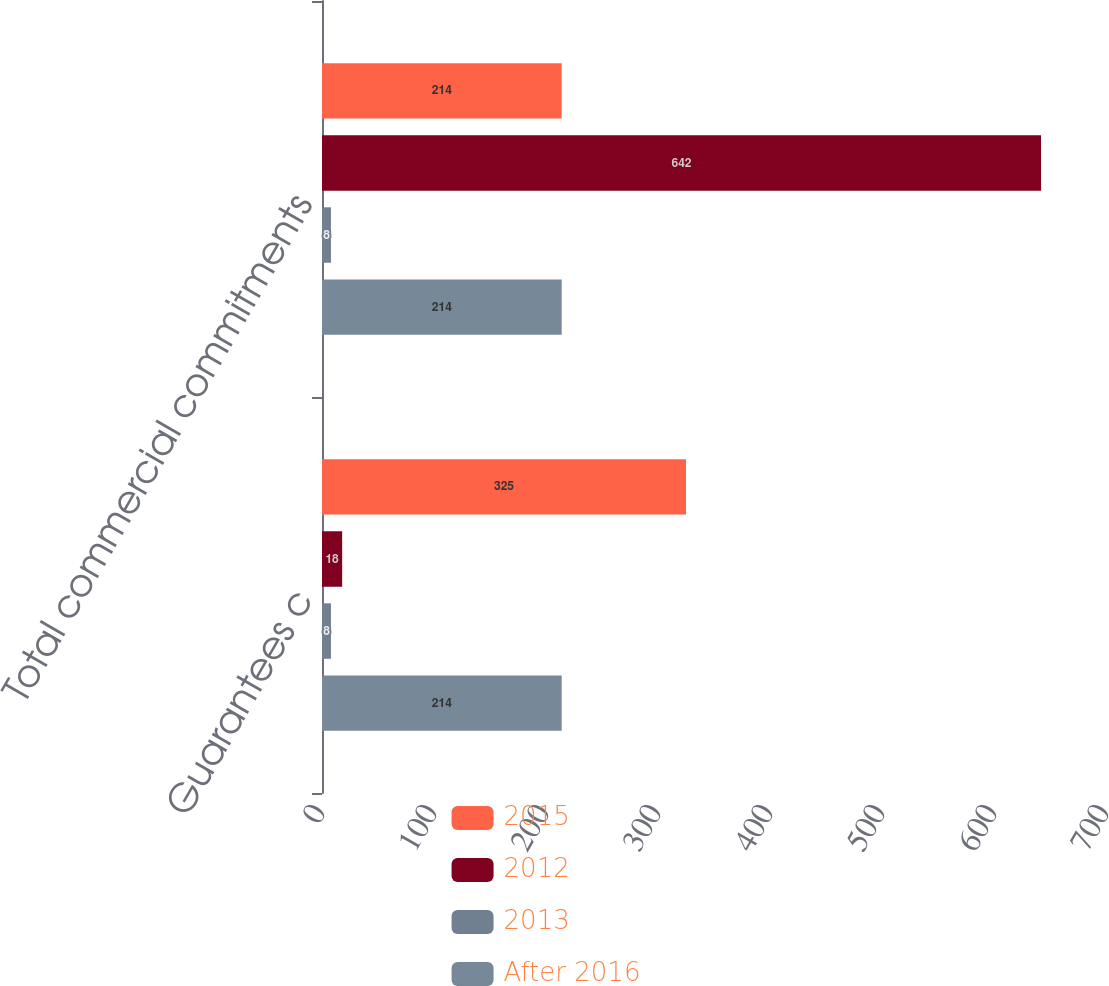Convert chart. <chart><loc_0><loc_0><loc_500><loc_500><stacked_bar_chart><ecel><fcel>Guarantees c<fcel>Total commercial commitments<nl><fcel>2015<fcel>325<fcel>214<nl><fcel>2012<fcel>18<fcel>642<nl><fcel>2013<fcel>8<fcel>8<nl><fcel>After 2016<fcel>214<fcel>214<nl></chart> 